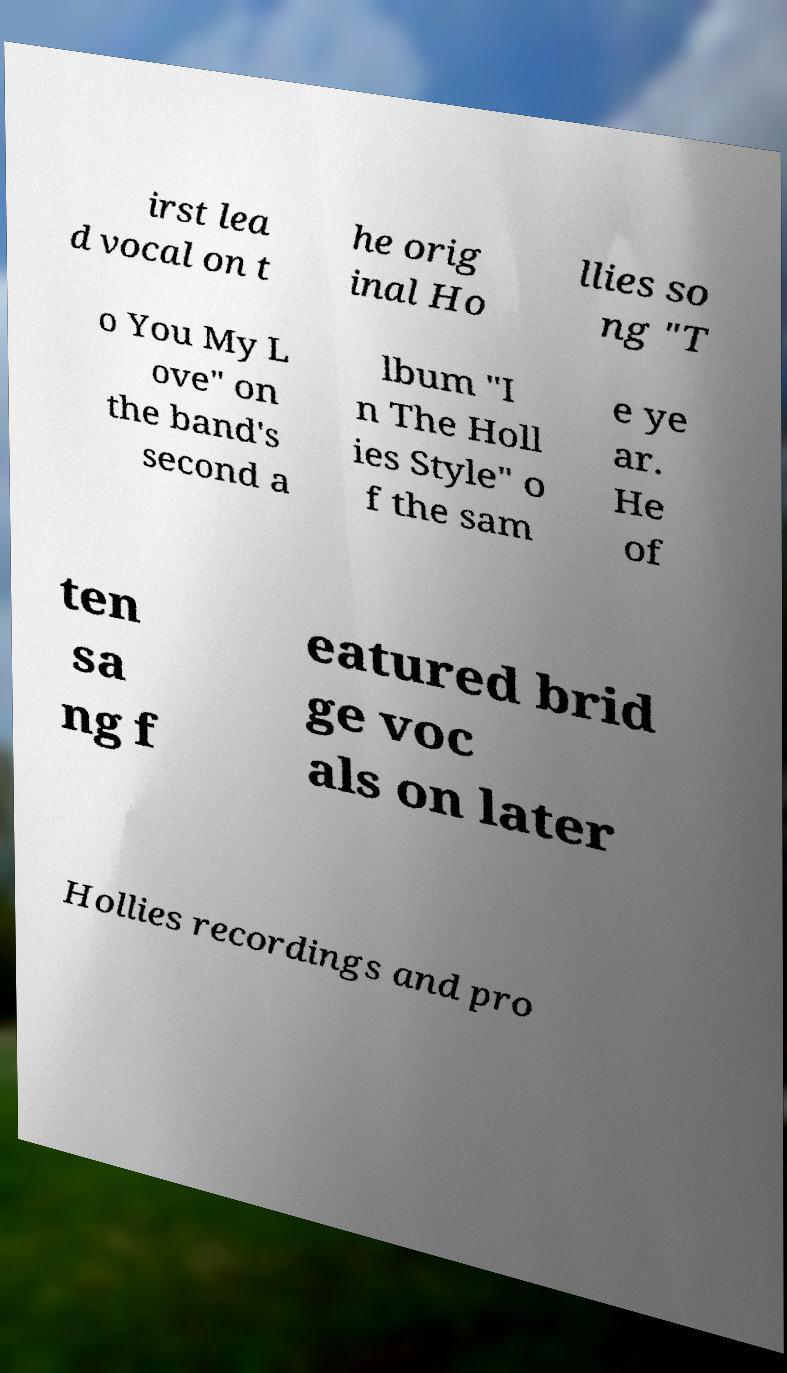Please read and relay the text visible in this image. What does it say? irst lea d vocal on t he orig inal Ho llies so ng "T o You My L ove" on the band's second a lbum "I n The Holl ies Style" o f the sam e ye ar. He of ten sa ng f eatured brid ge voc als on later Hollies recordings and pro 